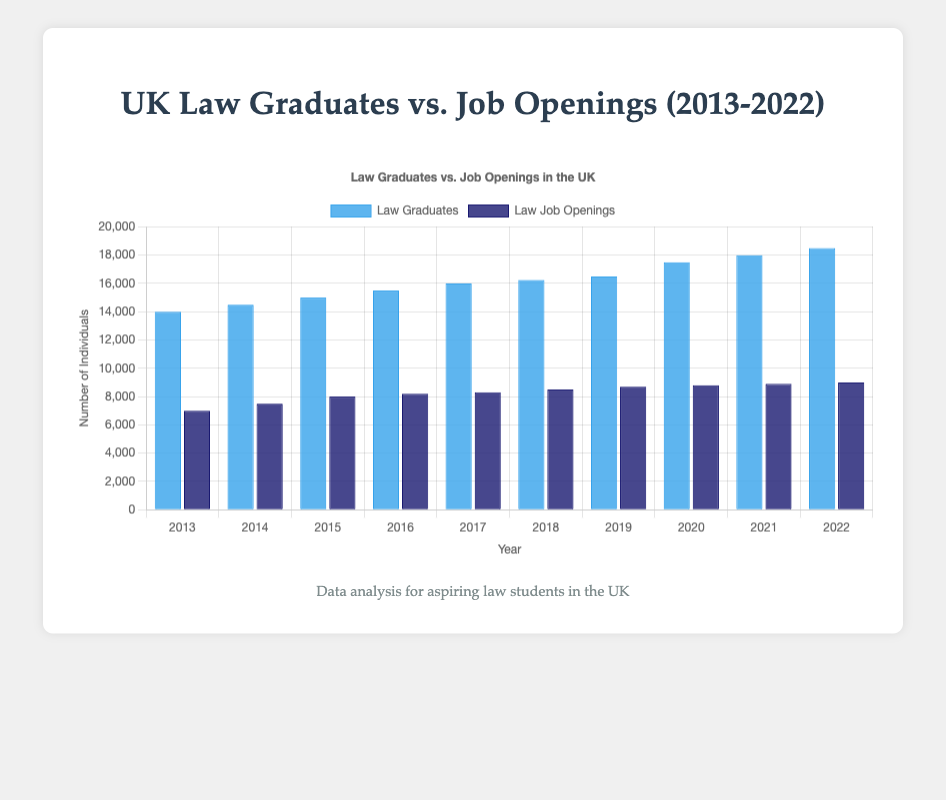How many more law graduates were there than law job openings in 2022? To find the difference, subtract the number of law job openings from the number of law graduates in 2022: 18500 - 9000
Answer: 9500 What was the average number of law graduates per year from 2013 to 2022? Sum the number of law graduates from each year and divide by the number of years (10): (14000 + 14500 + 15000 + 15500 + 16000 + 16250 + 16500 + 17500 + 18000 + 18500) / 10 = 16175
Answer: 16175 In which year was the gap between law graduates and job openings the widest? To find this, calculate the difference for each year and compare: 2013: 7000, 2014: 7000, 2015: 7000, 2016: 7300, 2017: 7700, 2018: 7750, 2019: 7800, 2020: 8700, 2021: 9100, 2022: 9500. The widest gap is in 2022.
Answer: 2022 In 2019, how much higher was the number of law graduates compared to law job openings? Subtract the number of job openings from the number of graduates in 2019: 16500 - 8700 = 7800
Answer: 7800 What trend do you observe in law job openings from 2013 to 2022? Observe the numbers over the years; they show an upward trend, increasing every year: (7000, 7500, 8000, 8200, 8300, 8500, 8700, 8800, 8900, 9000)
Answer: Increasing trend What is the combined total of law graduates and job openings in 2018? Add the number of law graduates and job openings in 2018: 16250 + 8500
Answer: 24750 Which year had the smallest number of law job openings, and what was that number? By referring to the data, 2013 had the smallest number of job openings: 7000
Answer: 2013 What was the percentage increase in law job openings from 2013 to 2018? Calculate the percentage increase with the formula [(8500 - 7000) / 7000] * 100 = 21.4%
Answer: 21.4% How do the heights of the bars for law graduates and job openings compare visually in 2020? The bar for law graduates is approximately twice as high as the bar for job openings.
Answer: About twice as high 